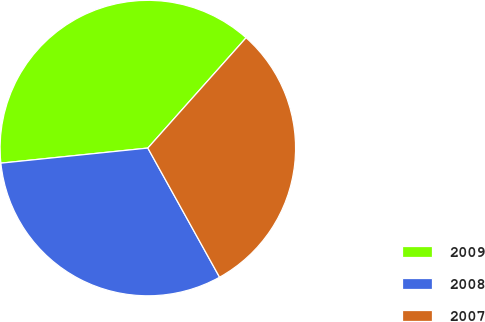<chart> <loc_0><loc_0><loc_500><loc_500><pie_chart><fcel>2009<fcel>2008<fcel>2007<nl><fcel>38.21%<fcel>31.44%<fcel>30.35%<nl></chart> 